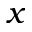<formula> <loc_0><loc_0><loc_500><loc_500>x</formula> 